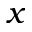<formula> <loc_0><loc_0><loc_500><loc_500>x</formula> 